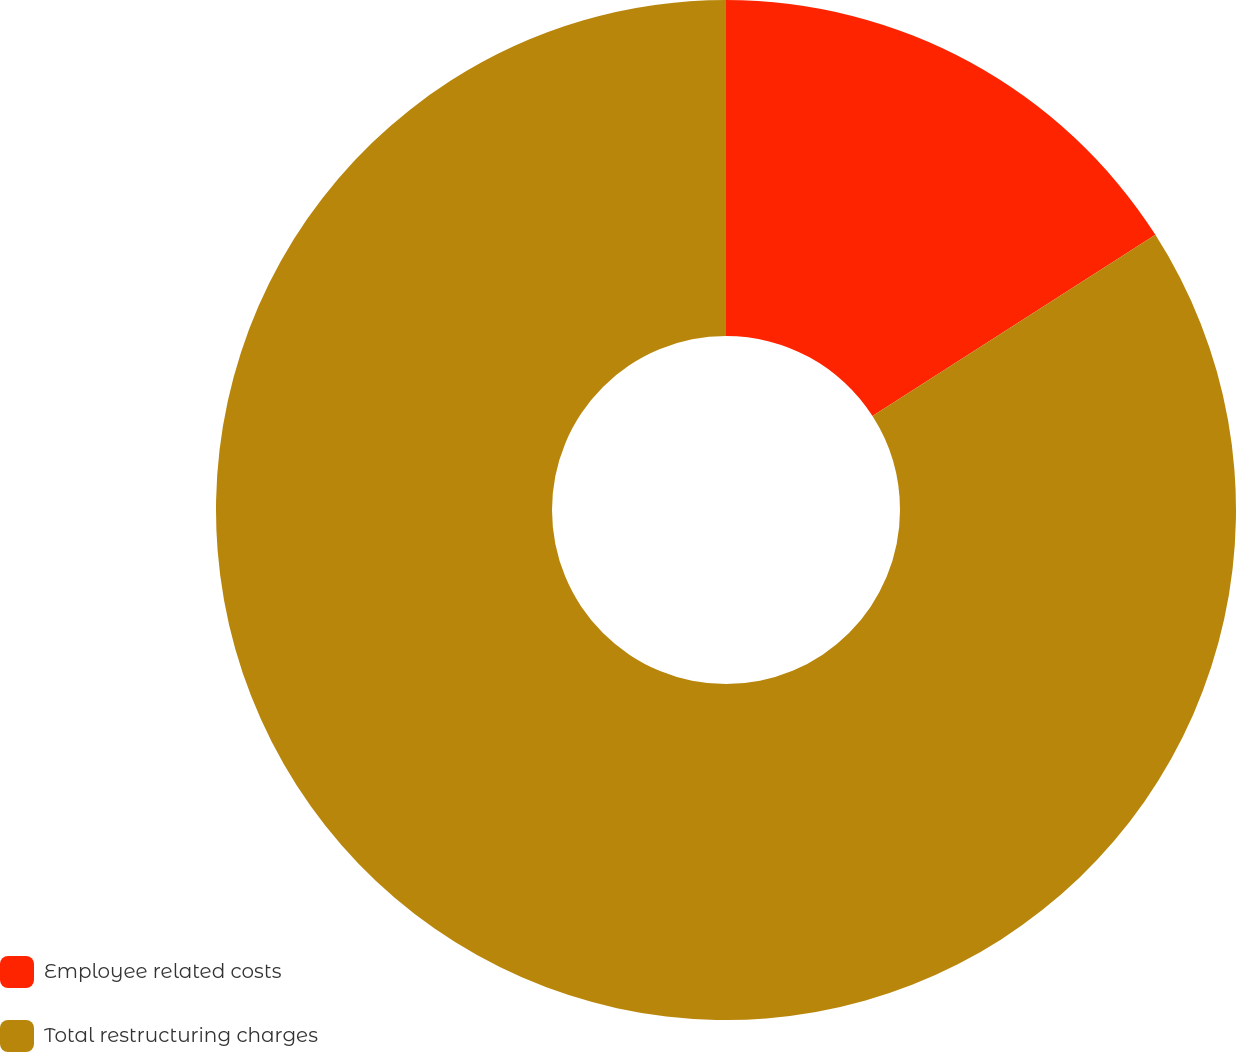<chart> <loc_0><loc_0><loc_500><loc_500><pie_chart><fcel>Employee related costs<fcel>Total restructuring charges<nl><fcel>15.93%<fcel>84.07%<nl></chart> 